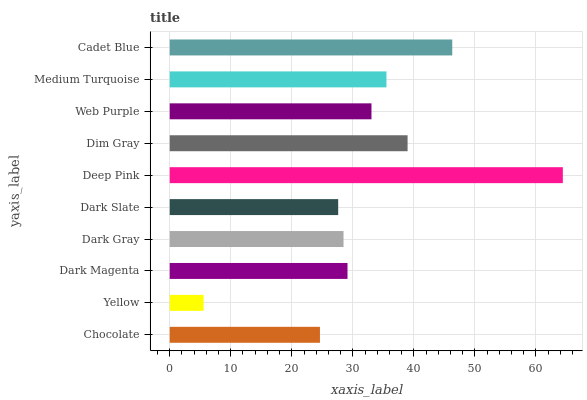Is Yellow the minimum?
Answer yes or no. Yes. Is Deep Pink the maximum?
Answer yes or no. Yes. Is Dark Magenta the minimum?
Answer yes or no. No. Is Dark Magenta the maximum?
Answer yes or no. No. Is Dark Magenta greater than Yellow?
Answer yes or no. Yes. Is Yellow less than Dark Magenta?
Answer yes or no. Yes. Is Yellow greater than Dark Magenta?
Answer yes or no. No. Is Dark Magenta less than Yellow?
Answer yes or no. No. Is Web Purple the high median?
Answer yes or no. Yes. Is Dark Magenta the low median?
Answer yes or no. Yes. Is Dark Slate the high median?
Answer yes or no. No. Is Yellow the low median?
Answer yes or no. No. 